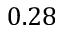<formula> <loc_0><loc_0><loc_500><loc_500>0 . 2 8</formula> 